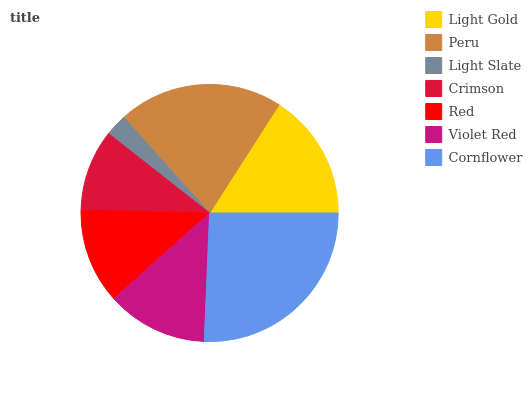Is Light Slate the minimum?
Answer yes or no. Yes. Is Cornflower the maximum?
Answer yes or no. Yes. Is Peru the minimum?
Answer yes or no. No. Is Peru the maximum?
Answer yes or no. No. Is Peru greater than Light Gold?
Answer yes or no. Yes. Is Light Gold less than Peru?
Answer yes or no. Yes. Is Light Gold greater than Peru?
Answer yes or no. No. Is Peru less than Light Gold?
Answer yes or no. No. Is Violet Red the high median?
Answer yes or no. Yes. Is Violet Red the low median?
Answer yes or no. Yes. Is Light Gold the high median?
Answer yes or no. No. Is Crimson the low median?
Answer yes or no. No. 